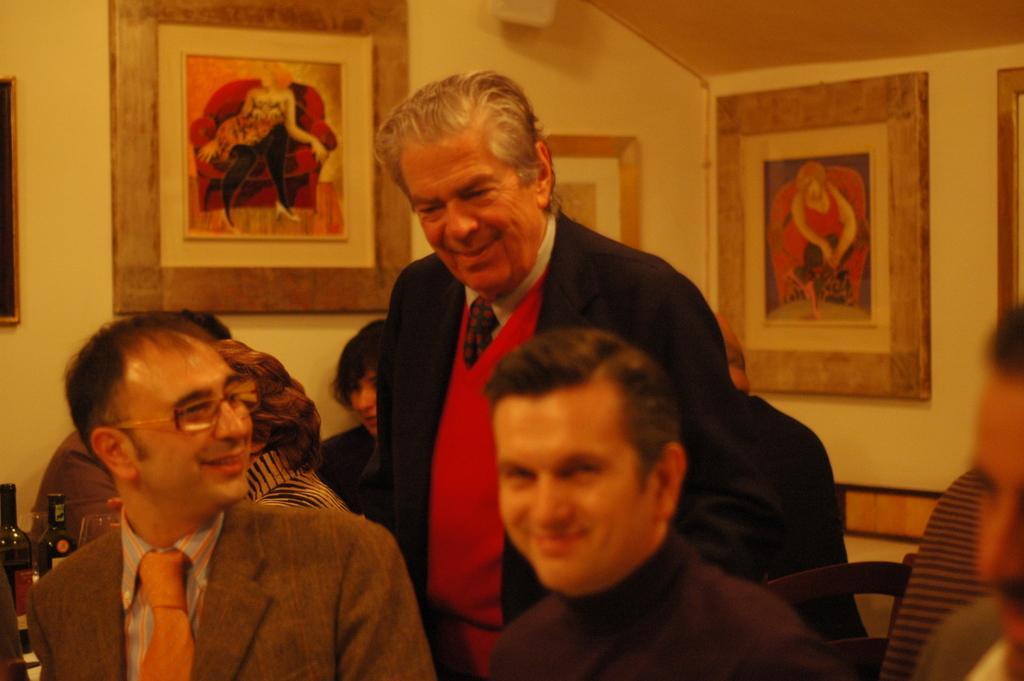Could you give a brief overview of what you see in this image? In the foreground of this image, there are three people sitting and a man standing behind them. In the background, there are three people, few bottles and few frames on the wall. 